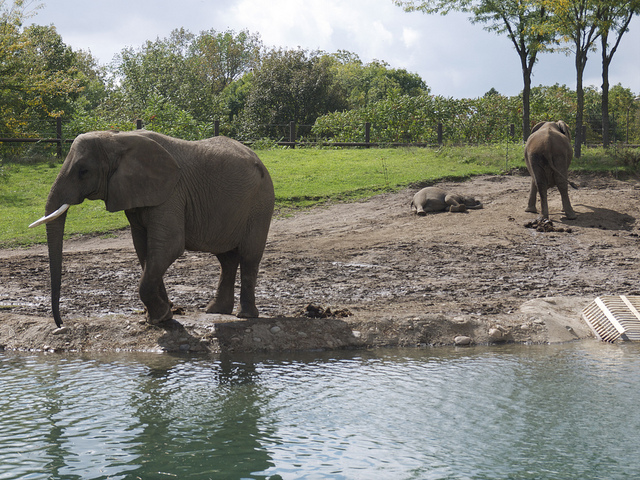How many tails can you see in this picture? Upon close inspection of the image, it appears that there are actually no visible tails. We can see a couple of elephants, one of which is closer to the water and therefore may have its tail obscured from view, while the other elephant in the background is lying on the ground in such a way that its tail is not visible. 